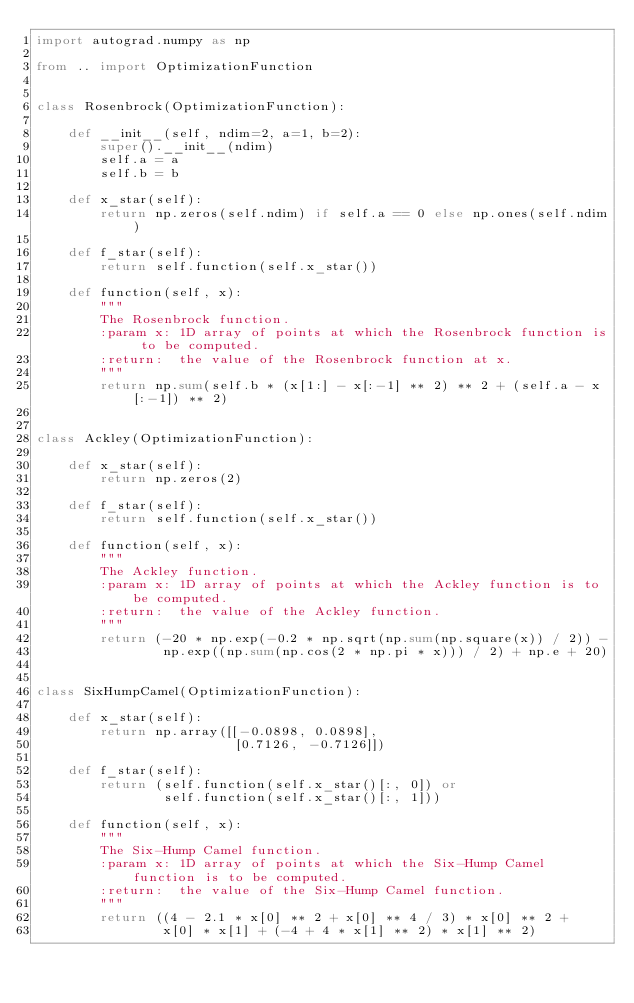Convert code to text. <code><loc_0><loc_0><loc_500><loc_500><_Python_>import autograd.numpy as np

from .. import OptimizationFunction


class Rosenbrock(OptimizationFunction):

    def __init__(self, ndim=2, a=1, b=2):
        super().__init__(ndim)
        self.a = a
        self.b = b

    def x_star(self):
        return np.zeros(self.ndim) if self.a == 0 else np.ones(self.ndim)

    def f_star(self):
        return self.function(self.x_star())

    def function(self, x):
        """
        The Rosenbrock function.
        :param x: 1D array of points at which the Rosenbrock function is to be computed.
        :return:  the value of the Rosenbrock function at x.
        """
        return np.sum(self.b * (x[1:] - x[:-1] ** 2) ** 2 + (self.a - x[:-1]) ** 2)


class Ackley(OptimizationFunction):

    def x_star(self):
        return np.zeros(2)

    def f_star(self):
        return self.function(self.x_star())

    def function(self, x):
        """
        The Ackley function.
        :param x: 1D array of points at which the Ackley function is to be computed.
        :return:  the value of the Ackley function.
        """
        return (-20 * np.exp(-0.2 * np.sqrt(np.sum(np.square(x)) / 2)) -
                np.exp((np.sum(np.cos(2 * np.pi * x))) / 2) + np.e + 20)


class SixHumpCamel(OptimizationFunction):

    def x_star(self):
        return np.array([[-0.0898, 0.0898],
                         [0.7126, -0.7126]])

    def f_star(self):
        return (self.function(self.x_star()[:, 0]) or
                self.function(self.x_star()[:, 1]))

    def function(self, x):
        """
        The Six-Hump Camel function.
        :param x: 1D array of points at which the Six-Hump Camel function is to be computed.
        :return:  the value of the Six-Hump Camel function.
        """
        return ((4 - 2.1 * x[0] ** 2 + x[0] ** 4 / 3) * x[0] ** 2 +
                x[0] * x[1] + (-4 + 4 * x[1] ** 2) * x[1] ** 2)
</code> 